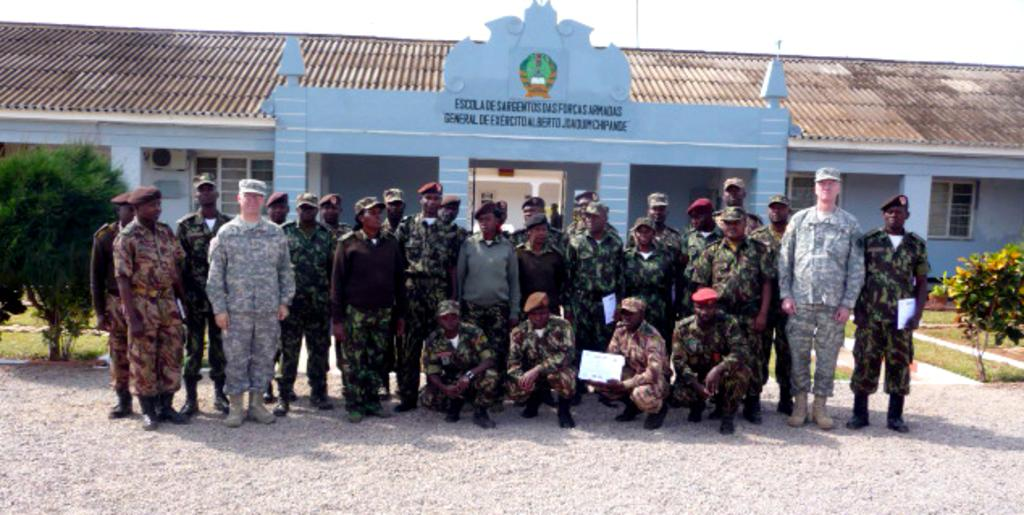What are the people in the image doing? Some people are standing, and some are sitting in a squat position. Can you describe the object being held by the man in the image? Unfortunately, the object cannot be identified from the image. What type of vegetation is visible in the image? There are plants and grass present in the image. What can be seen in the background of the image? There is a building and the sky visible in the background of the image. What type of jewel is the grandmother wearing in the image? There is no grandmother or jewel present in the image. What activity are the children participating in during recess in the image? There is no indication of children or a recess in the image. 